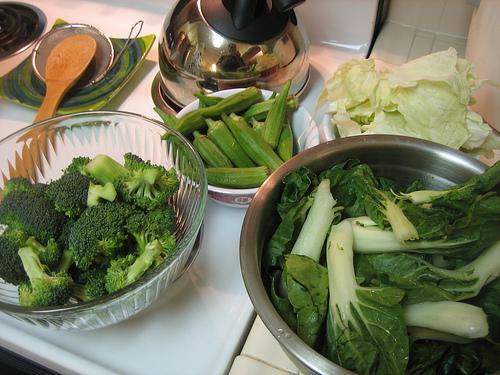Question: what food is in the dishes?
Choices:
A. Bokchoy, okra, broccoli,lettuce.
B. Chicken, rice, and carrots.
C. Beef, potatoes, mushrooms and onions.
D. Eggs, peppers, cheese, and sausage.
Answer with the letter. Answer: A Question: what is on the back burner?
Choices:
A. Frying pan.
B. Skillet.
C. Tea kettle.
D. Sauce pot.
Answer with the letter. Answer: C Question: why is it all vegetarian?
Choices:
A. Because vegetarians are eating.
B. No meat tonight.
C. Because She cant eat meat.
D. Because she likes veggies.
Answer with the letter. Answer: B Question: what color are all the vegetables?
Choices:
A. Green.
B. Red.
C. Light green.
D. Orange.
Answer with the letter. Answer: A 